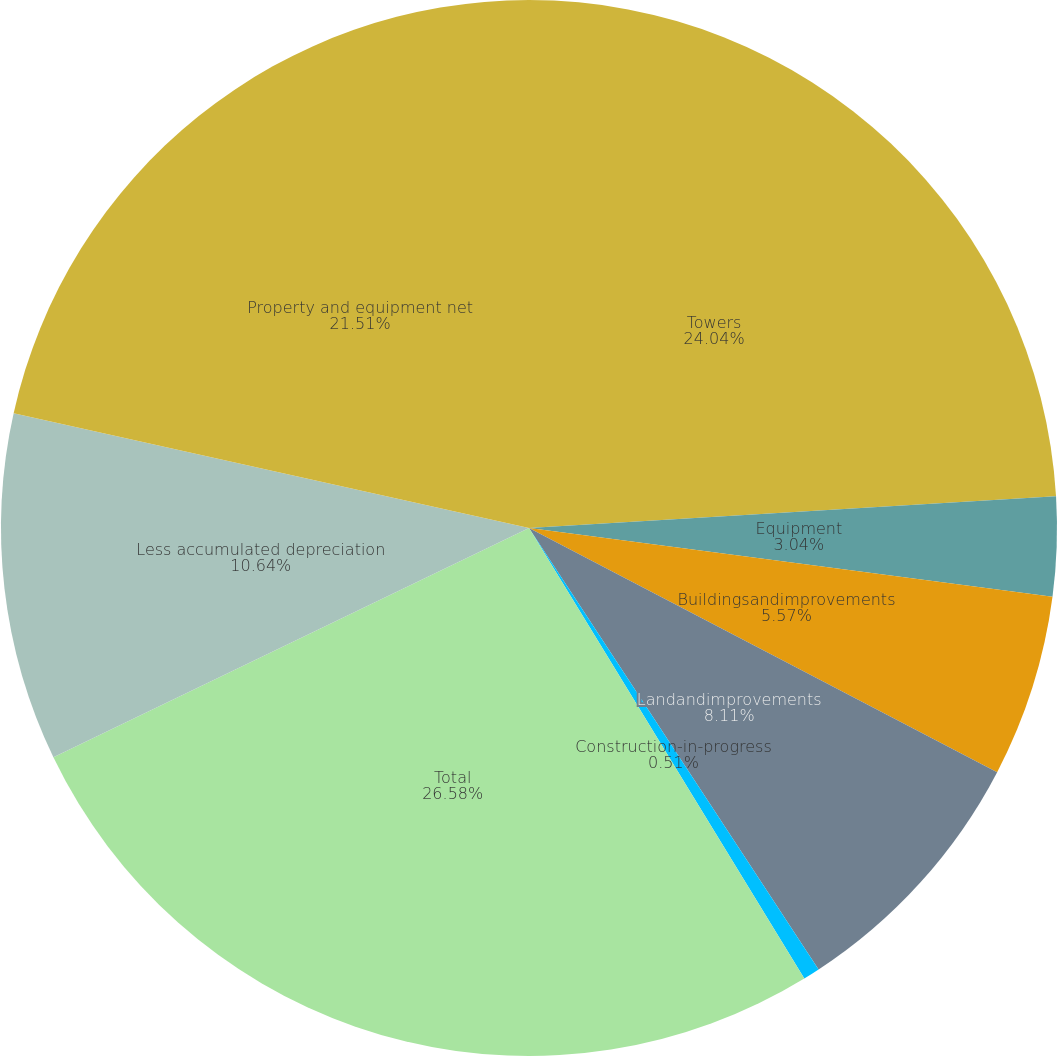Convert chart. <chart><loc_0><loc_0><loc_500><loc_500><pie_chart><fcel>Towers<fcel>Equipment<fcel>Buildingsandimprovements<fcel>Landandimprovements<fcel>Construction-in-progress<fcel>Total<fcel>Less accumulated depreciation<fcel>Property and equipment net<nl><fcel>24.04%<fcel>3.04%<fcel>5.57%<fcel>8.11%<fcel>0.51%<fcel>26.58%<fcel>10.64%<fcel>21.51%<nl></chart> 